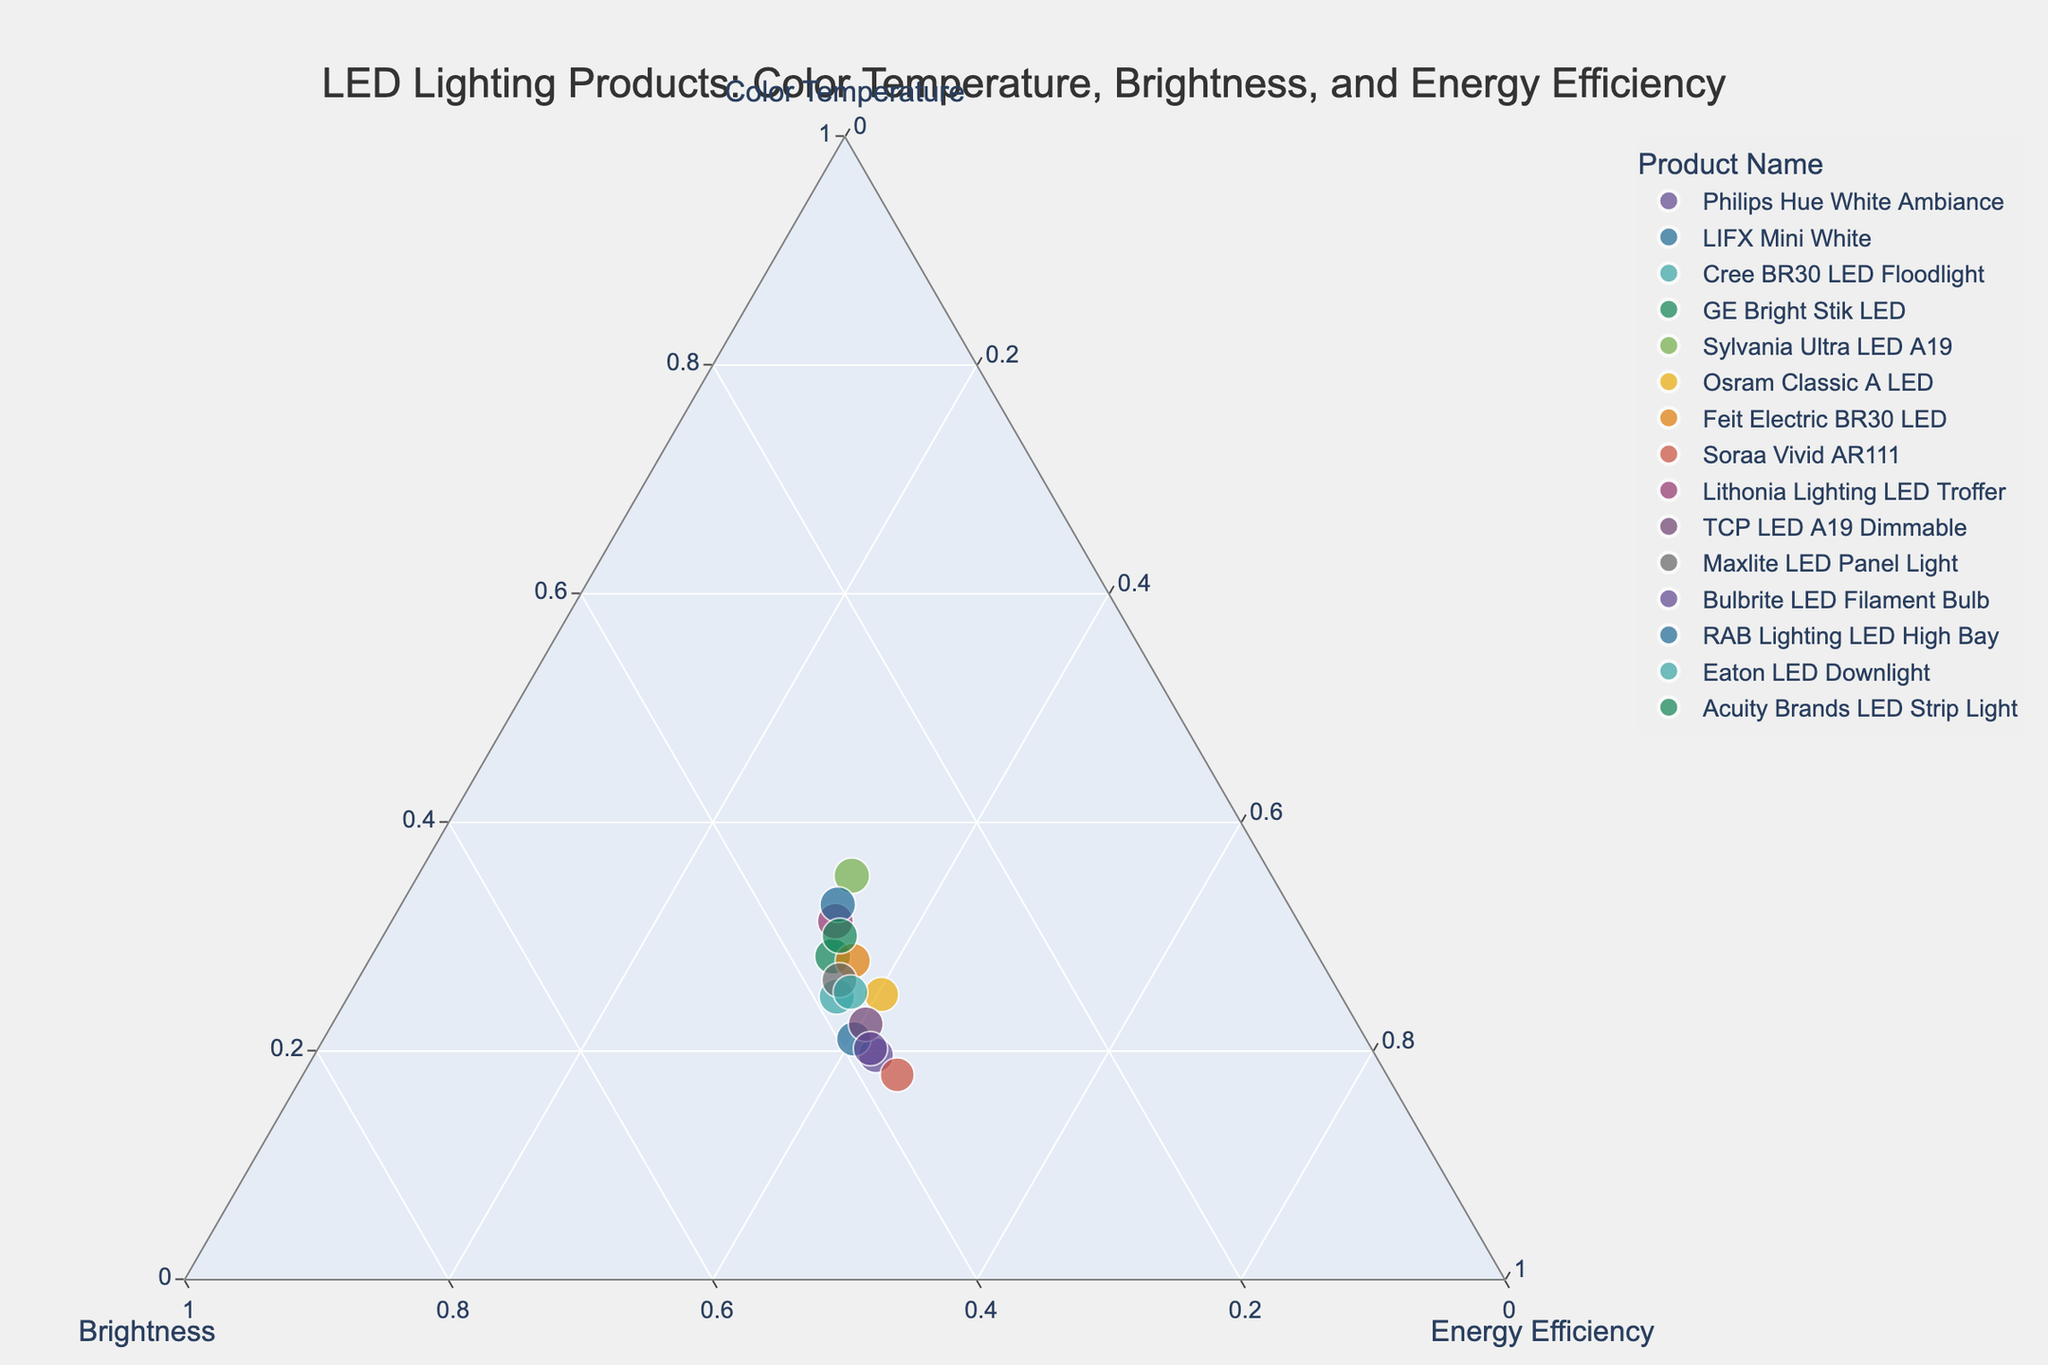What is the title of the ternary plot? The title of the ternary plot is displayed at the top center of the plot. It reads, "LED Lighting Products: Color Temperature, Brightness, and Energy Efficiency."
Answer: LED Lighting Products: Color Temperature, Brightness, and Energy Efficiency How many data points are represented on the ternary plot? Each lighting product listed in the data is represented by a data point on the ternary plot. There are 15 products, so there are 15 data points.
Answer: 15 Which product has the highest brightness percentage? By examining the brightness axis and hover information, the product with the highest brightness percentage is the GE Bright Stik LED with a brightness of 100%.
Answer: GE Bright Stik LED Which product has the lowest energy efficiency percentage? By checking the energy efficiency axis and the hover information, the product with the lowest energy efficiency is the Soraa Vivid AR111 with an energy efficiency of 85%.
Answer: Soraa Vivid AR111 How does the color temperature of the Philips Hue White Ambiance compare to the Lithonia Lighting LED Troffer? By comparing their positions and hover details on the ternary plot, the color temperature of the Philips Hue White Ambiance is 2700 K, while the Lithonia Lighting LED Troffer is 5700 K. The latter has a higher color temperature.
Answer: Lithonia Lighting LED Troffer has a higher color temperature Which product has the highest energy efficiency and how does its brightness compare to the Philips Hue White Ambiance? The highest energy efficiency product is the GE Bright Stik LED with 95% efficiency. Comparing brightness, the GE Bright Stik LED has 100% brightness, and the Philips Hue White Ambiance has 80% brightness. Hence, GE Bright Stik LED is brighter.
Answer: GE Bright Stik LED has 100% brightness, which is higher than Philips Hue White Ambiance's 80% What is the median value of brightness for all products? To find the median, first list all brightness values in ascending order: 70, 75, 78, 80, 82, 85, 86, 88, 88, 90, 92, 94, 95, 96, 98. The median is the middle value in this ordered list, which is 88.
Answer: 88 How many products have a color temperature above 5000 K? Products with a color temperature above 5000 K are LIFX Mini White, GE Bright Stik LED, Sylvania Ultra LED A19, and RAB Lighting LED High Bay. Counting them gives 4.
Answer: 4 Which product has the lowest brightness and how does its energy efficiency compare to the average energy efficiency of all products? The product with the lowest brightness is Soraa Vivid AR111 with 70%. To compare its energy efficiency, first compute the average energy efficiency: (90 + 88 + 92 + 95 + 93 + 87 + 91 + 85 + 94 + 89 + 90 + 86 + 93 + 88 + 92) / 15 = 90. The Soraa Vivid AR111 has 85% energy efficiency, which is lower than the average of 90%.
Answer: Soraa Vivid AR111 has lower energy efficiency (85%) compared to the average (90%) What are the three products with the highest color temperature? Based on the hover details and color temperature axis, the three products with the highest color temperatures are Lithonia Lighting LED Troffer (5700 K), RAB Lighting LED High Bay (6000 K), and Sylvania Ultra LED A19 (6500 K).
Answer: Sylvania Ultra LED A19, RAB Lighting LED High Bay, Lithonia Lighting LED Troffer 